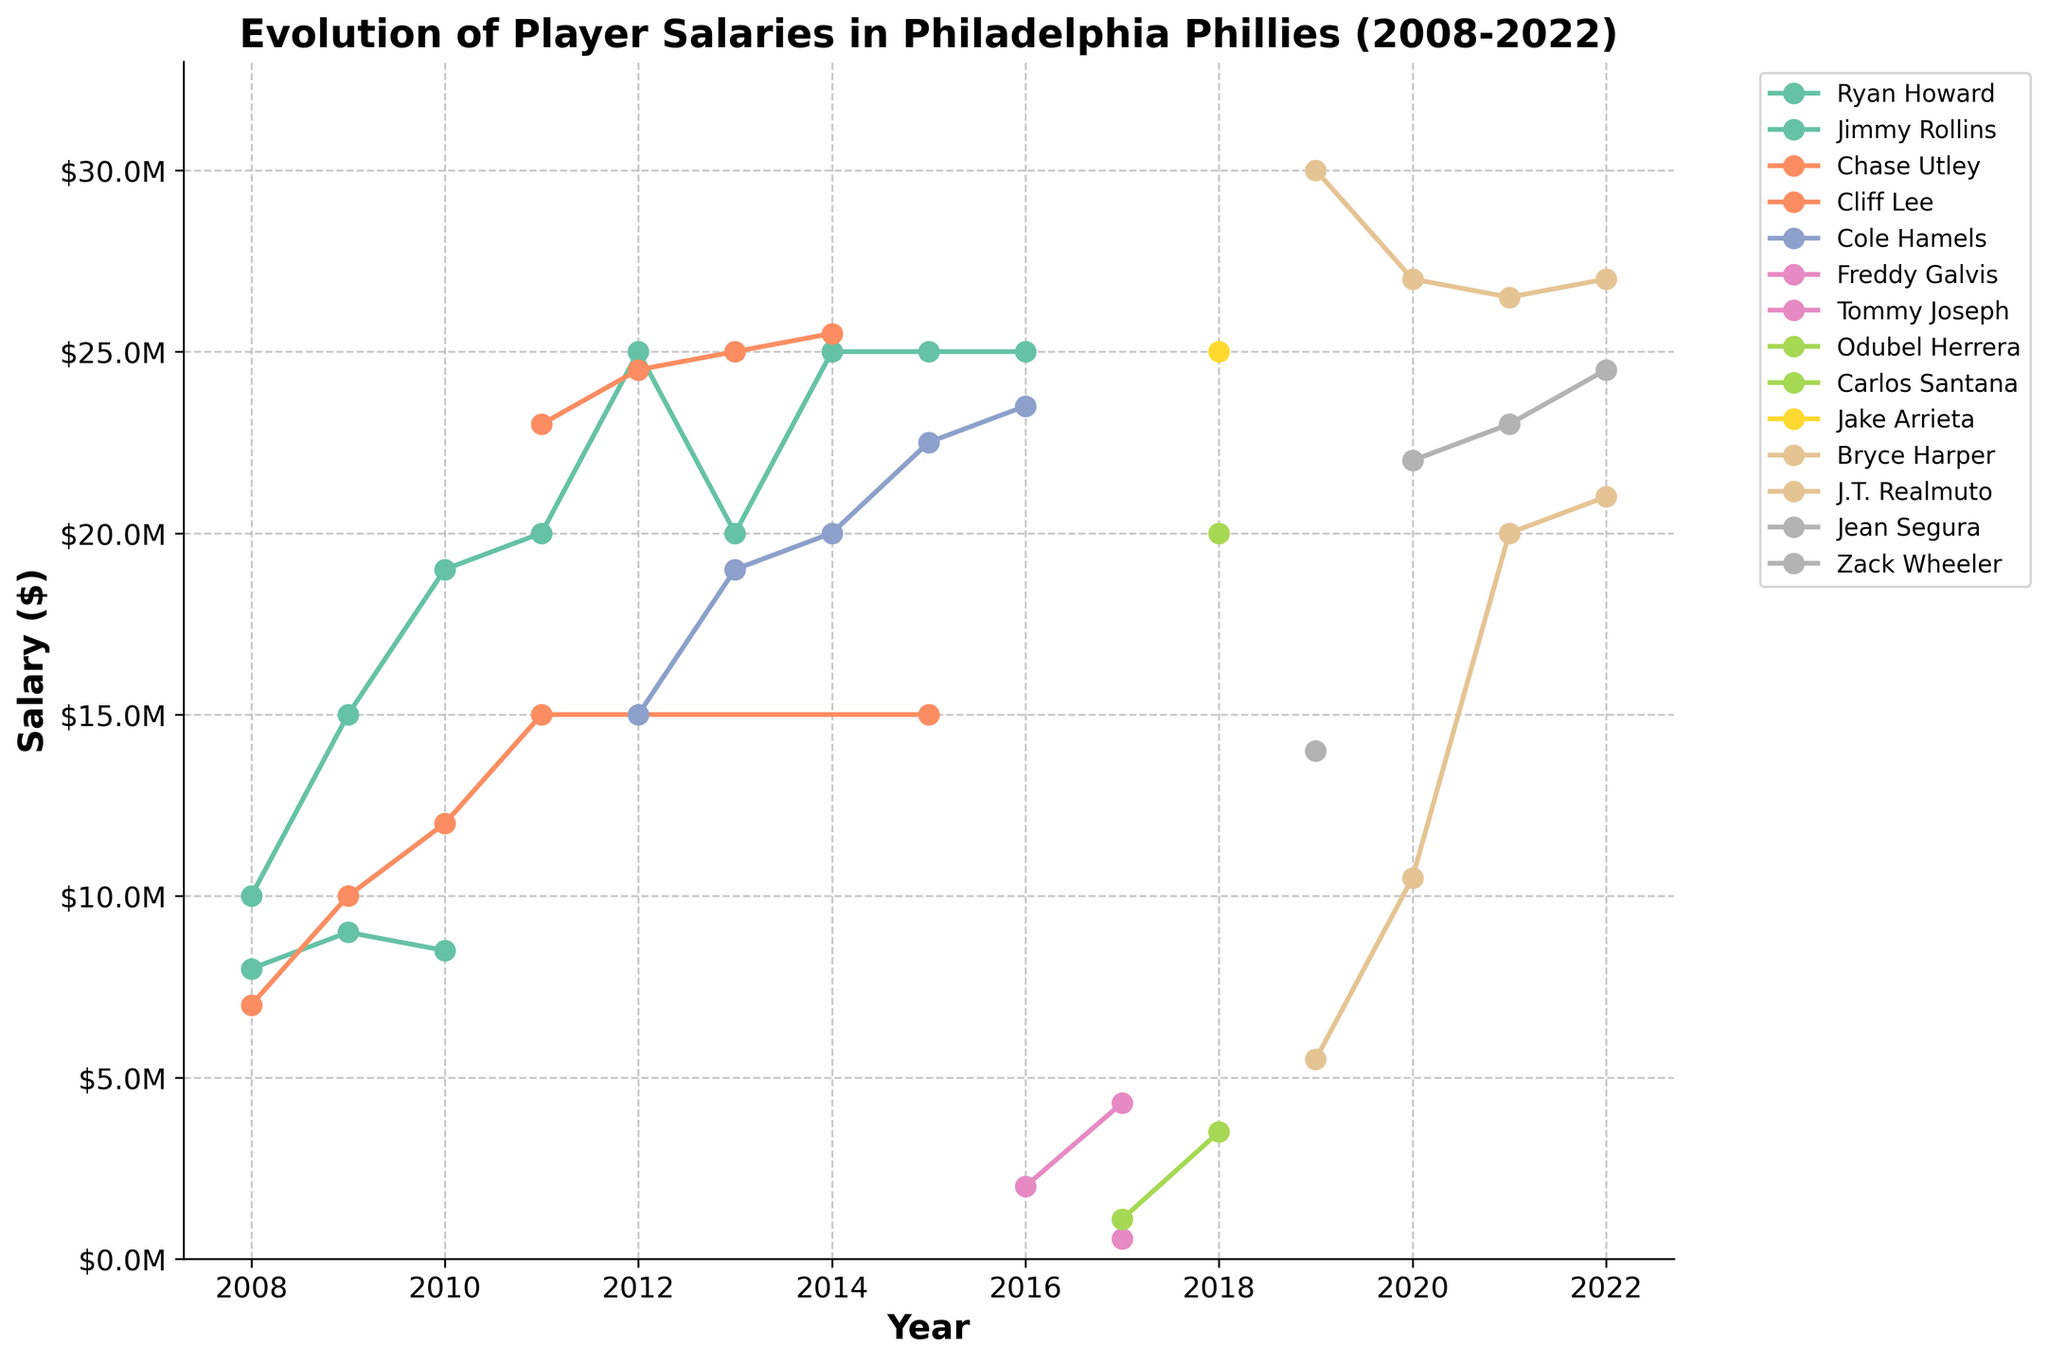What year did Ryan Howard earn his highest salary, and what was the amount? Ryan Howard's salary information is plotted along the years. Observing the highest point in the plot related to Ryan Howard shows that his highest salary occurred in 2014 at $25,000,000.
Answer: 2014, $25,000,000 Which player earned the highest salary in 2019? Comparing the salary lines in 2019, Bryce Harper's line is the highest, indicating he had the highest salary in 2019, which is $30,000,000.
Answer: Bryce Harper How did the salary of Cole Hamels evolve from 2012 to 2016? Tracing the line associated with Cole Hamels from 2012 to 2016, we see his salary starts at $15,000,000 in 2012, increases to $19,000,000 in 2013, $20,000,000 in 2014, $22,500,000 in 2015, and finally to $23,500,000 in 2016, indicating a gradually increasing trend.
Answer: Increased from $15,000,000 to $23,500,000 Between 2018 and 2022, which player has shown the highest upward spike in salary? Looking at the highest vertical movement between 2018 and 2022, J.T. Realmuto's salary increases notably from $5,500,000 in 2019 to $10,500,000 in 2020 and then to $20,000,000 in 2021, showing the highest upward spike.
Answer: J.T. Realmuto What is the average salary for Chase Utley across the years he has data points? Chase Utley's salaries are plotted for the years 2008, 2009, 2010, 2011, and 2015. Calculating the average, ($7,000,000 + $10,000,000 + $12,000,000 + $15,000,000 + $15,000,000) / 5 = $11,800,000.
Answer: $11,800,000 In which year did Cliff Lee's salary reach its peak, and what was the amount? Observing the peak salary for Cliff Lee's salary line, it reaches its highest point in 2014 with a salary of $25,500,000.
Answer: 2014, $25,500,000 How does Freddy Galvis' salary in 2017 compare to his salary in 2016? Comparing Freddy Galvis' salary points for 2016 and 2017, his salary increased from $2,000,000 in 2016 to $4,300,000 in 2017.
Answer: Increased by $2,300,000 Which player had the most significant drop in salary from one year to another, and what was the amount of the drop? Observing the declines, Tommy Joseph had a significant drop from $550,000 in 2017 (starting point) to no data for subsequent years, indicating a complete drop. In terms of recorded data, Cliff Lee from 2014 ($25,500,000) to 2015 (no data) is also noteworthy given no salary is recorded post-2014 indicating his departure/retirement.
Answer: Tommy Joseph, $550,000 How many players had a salary of at least $20,000,000 in 2018? Checking the 2018 data points, both Carlos Santana and Jake Arrieta had salaries of at least $20,000,000. So, that makes two players in total.
Answer: 2 players 